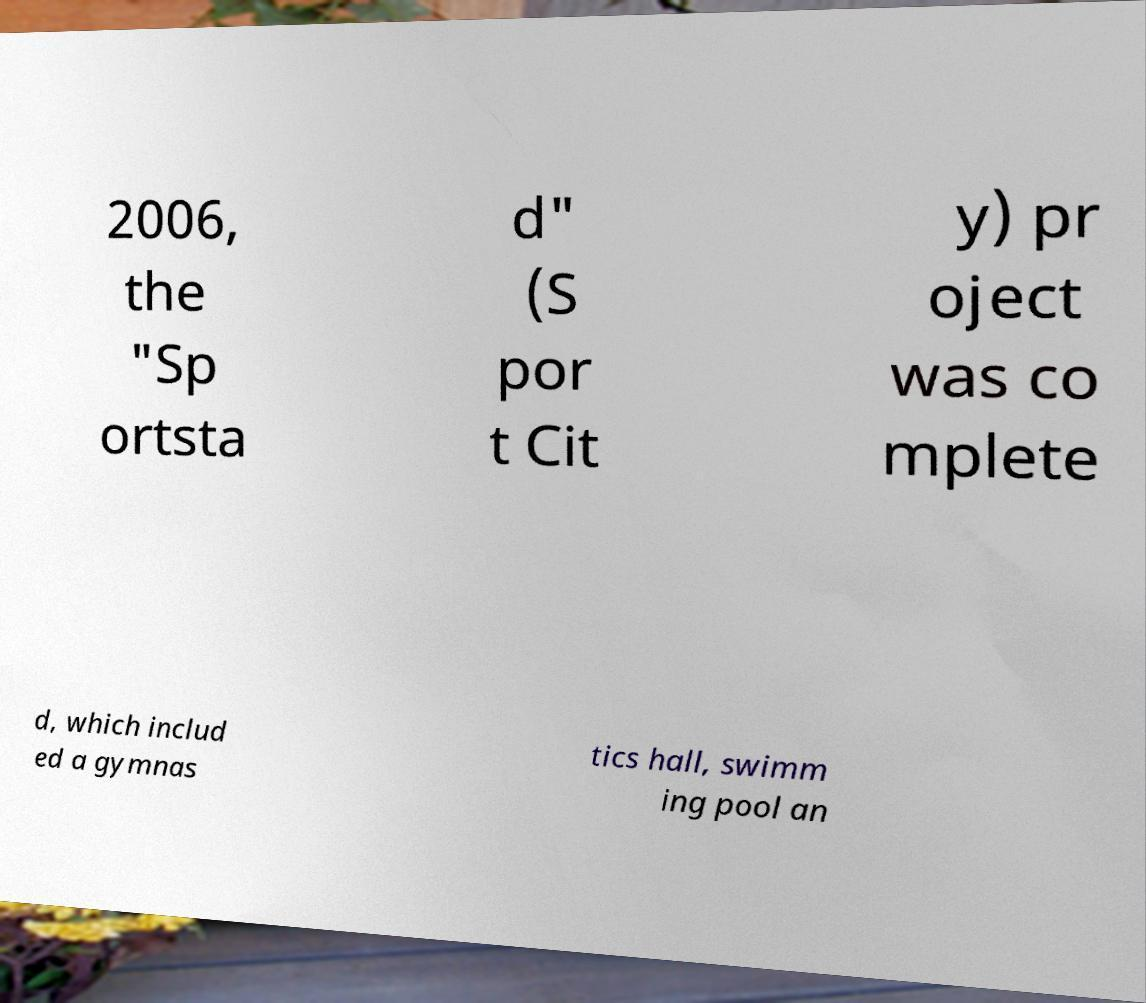What messages or text are displayed in this image? I need them in a readable, typed format. 2006, the "Sp ortsta d" (S por t Cit y) pr oject was co mplete d, which includ ed a gymnas tics hall, swimm ing pool an 